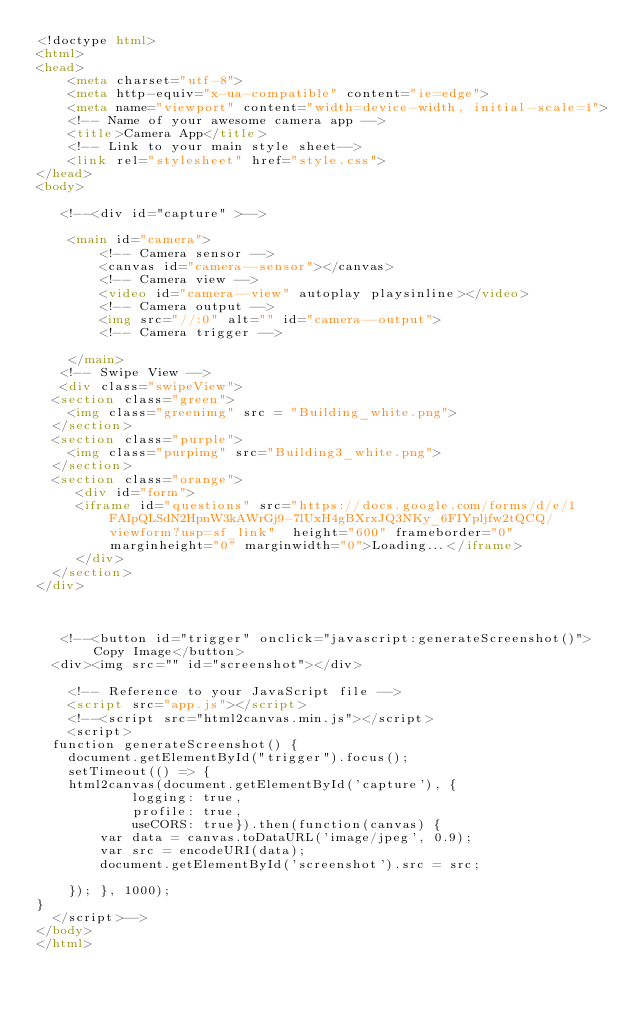Convert code to text. <code><loc_0><loc_0><loc_500><loc_500><_HTML_><!doctype html>
<html>
<head>
    <meta charset="utf-8">
    <meta http-equiv="x-ua-compatible" content="ie=edge">
    <meta name="viewport" content="width=device-width, initial-scale=1">
    <!-- Name of your awesome camera app -->
    <title>Camera App</title>
    <!-- Link to your main style sheet-->
    <link rel="stylesheet" href="style.css">
</head>
<body>
   
   <!--<div id="capture" >-->

    <main id="camera">
        <!-- Camera sensor -->
        <canvas id="camera--sensor"></canvas>
        <!-- Camera view -->
        <video id="camera--view" autoplay playsinline></video>
        <!-- Camera output -->
        <img src="//:0" alt="" id="camera--output">
        <!-- Camera trigger -->
        
    </main>
   <!-- Swipe View -->
   <div class="swipeView">
  <section class="green">
    <img class="greenimg" src = "Building_white.png">
  </section>
  <section class="purple">
    <img class="purpimg" src="Building3_white.png">
  </section>
  <section class="orange">
     <div id="form">
     <iframe id="questions" src="https://docs.google.com/forms/d/e/1FAIpQLSdN2HpnW3kAWrGj9-7lUxH4gBXrxJQ3NKy_6FIYpljfw2tQCQ/viewform?usp=sf_link"  height="600" frameborder="0" marginheight="0" marginwidth="0">Loading...</iframe>
     </div>
  </section>
</div>


  
   <!--<button id="trigger" onclick="javascript:generateScreenshot()">Copy Image</button>
	<div><img src="" id="screenshot"></div>
   
    <!-- Reference to your JavaScript file -->
    <script src="app.js"></script>
    <!--<script src="html2canvas.min.js"></script>
    <script>
	function generateScreenshot() {
    document.getElementById("trigger").focus();
    setTimeout(() => {
    html2canvas(document.getElementById('capture'), {
            logging: true,
            profile: true,
            useCORS: true}).then(function(canvas) {
        var data = canvas.toDataURL('image/jpeg', 0.9);
        var src = encodeURI(data);
        document.getElementById('screenshot').src = src;
        
    }); }, 1000);
}
	</script>-->
</body>
</html></code> 